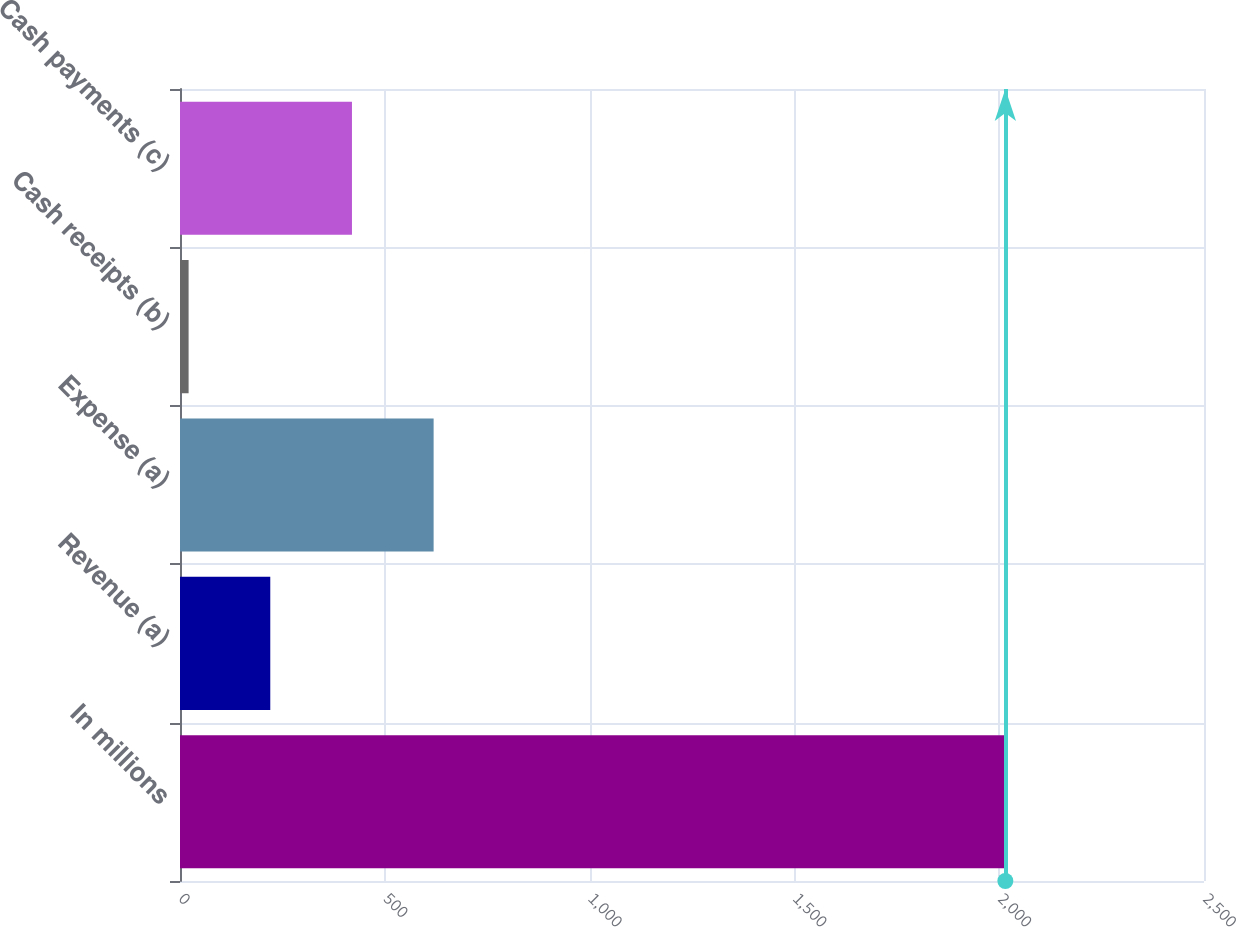Convert chart to OTSL. <chart><loc_0><loc_0><loc_500><loc_500><bar_chart><fcel>In millions<fcel>Revenue (a)<fcel>Expense (a)<fcel>Cash receipts (b)<fcel>Cash payments (c)<nl><fcel>2015<fcel>220.4<fcel>619.2<fcel>21<fcel>419.8<nl></chart> 